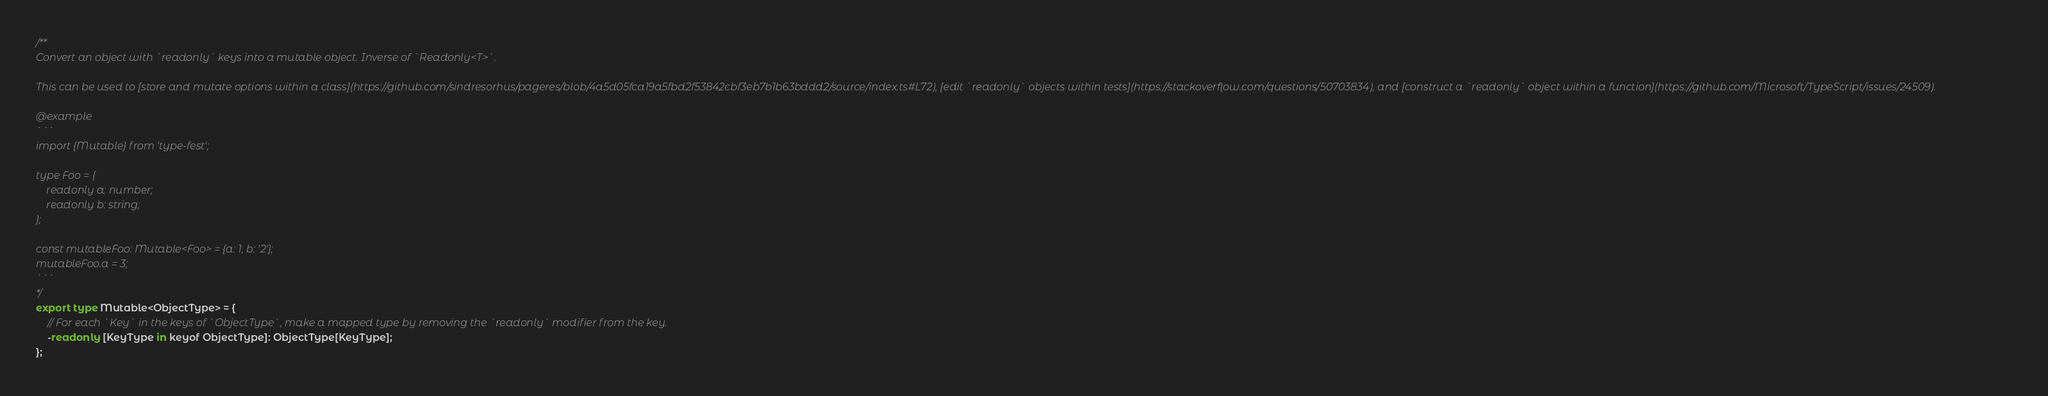Convert code to text. <code><loc_0><loc_0><loc_500><loc_500><_TypeScript_>/**
Convert an object with `readonly` keys into a mutable object. Inverse of `Readonly<T>`.

This can be used to [store and mutate options within a class](https://github.com/sindresorhus/pageres/blob/4a5d05fca19a5fbd2f53842cbf3eb7b1b63bddd2/source/index.ts#L72), [edit `readonly` objects within tests](https://stackoverflow.com/questions/50703834), and [construct a `readonly` object within a function](https://github.com/Microsoft/TypeScript/issues/24509).

@example
```
import {Mutable} from 'type-fest';

type Foo = {
	readonly a: number;
	readonly b: string;
};

const mutableFoo: Mutable<Foo> = {a: 1, b: '2'};
mutableFoo.a = 3;
```
*/
export type Mutable<ObjectType> = {
	// For each `Key` in the keys of `ObjectType`, make a mapped type by removing the `readonly` modifier from the key.
	-readonly [KeyType in keyof ObjectType]: ObjectType[KeyType];
};
</code> 